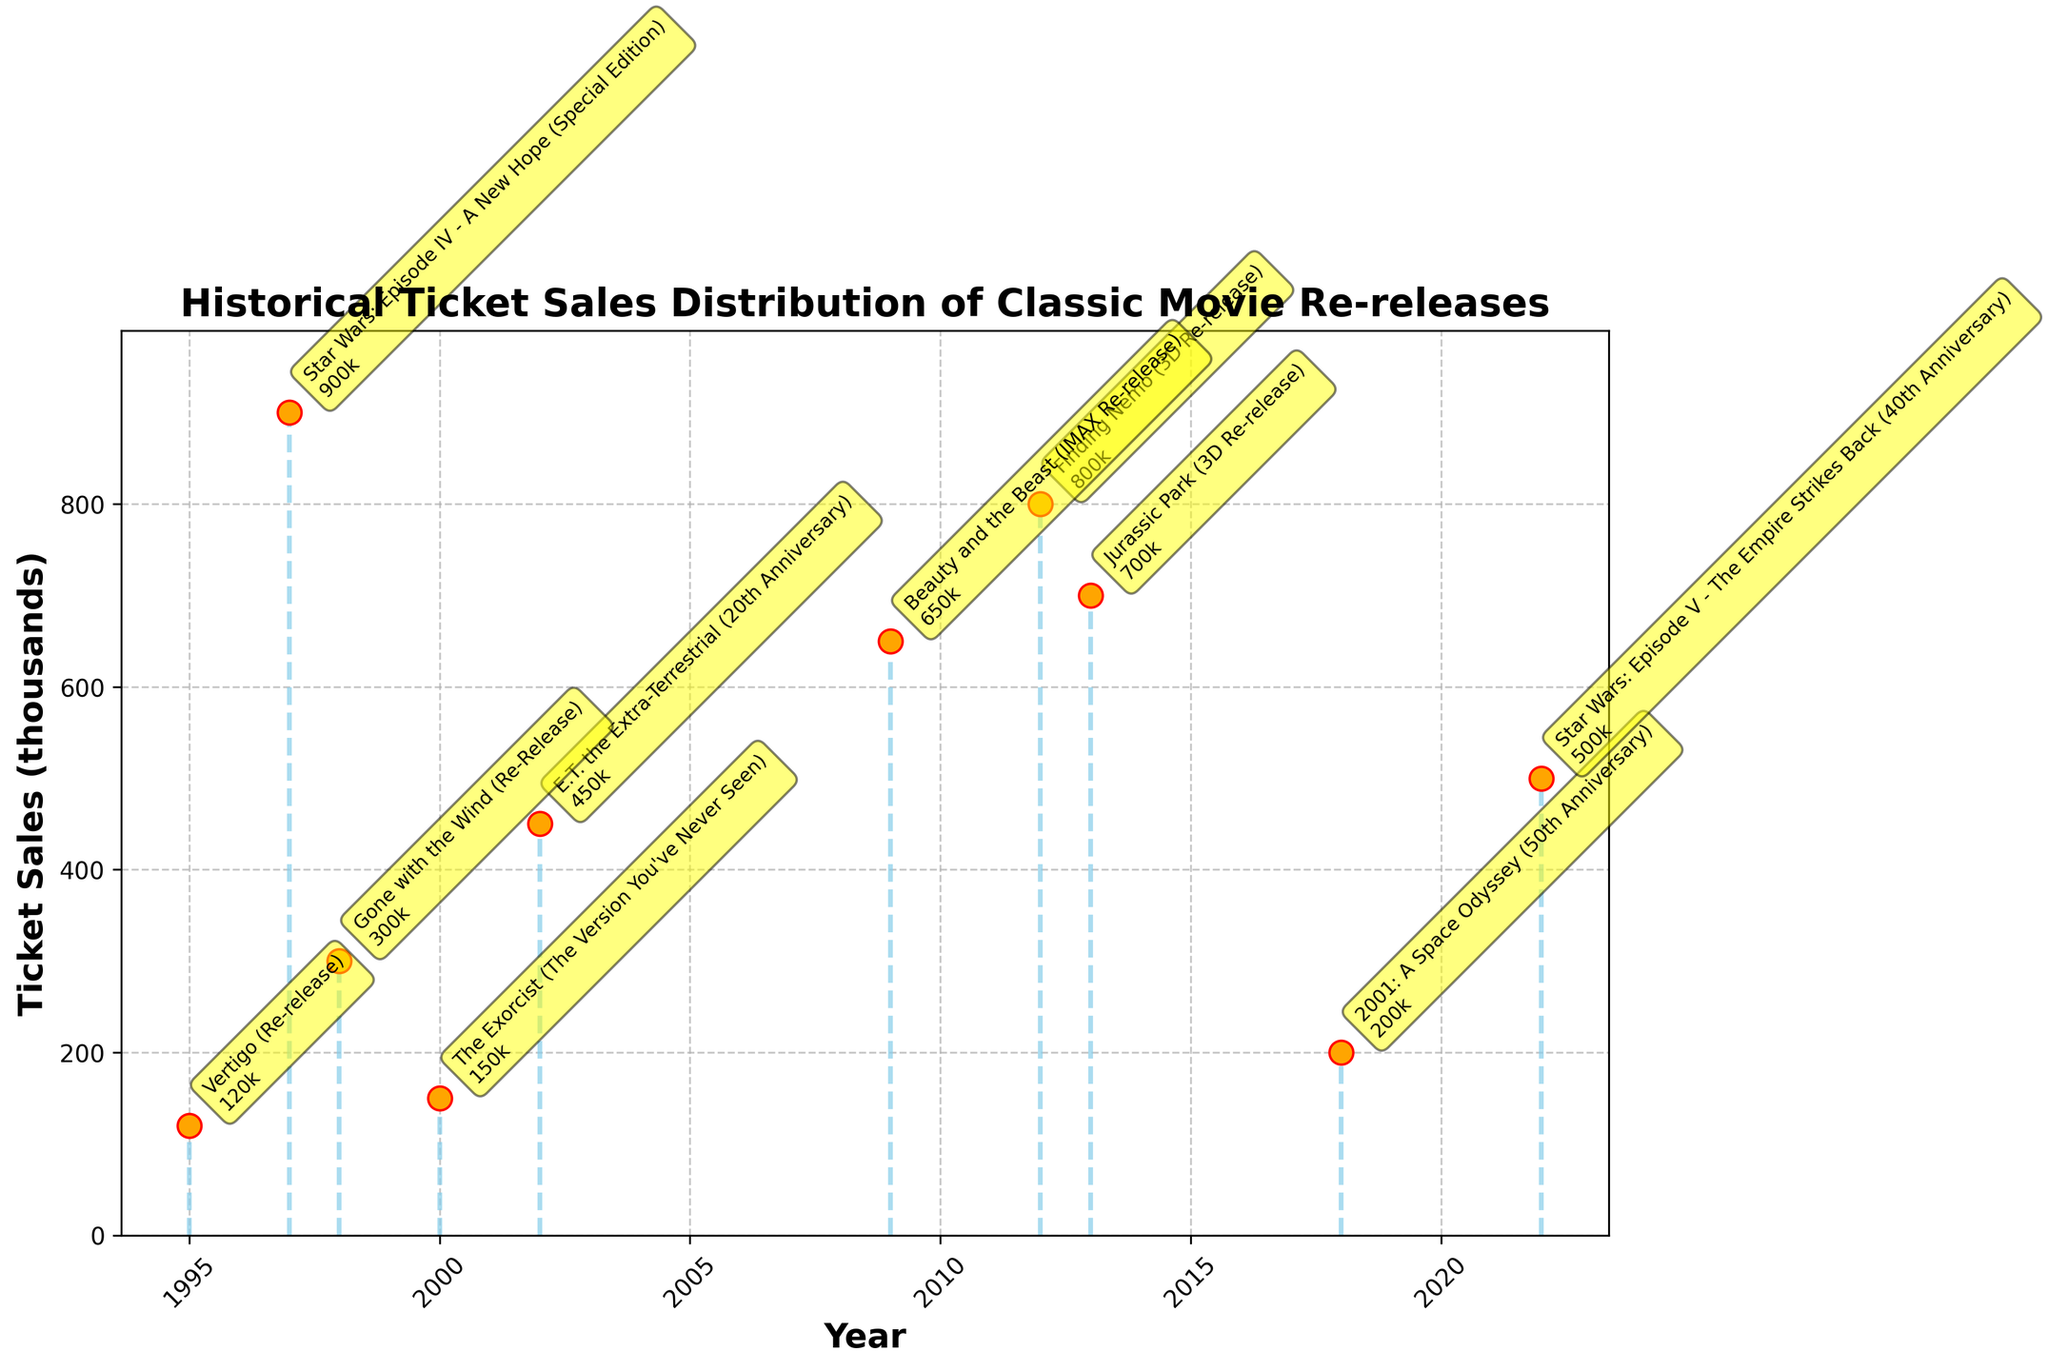Which classic movie re-release had the highest ticket sales? The highest ticket sales can be found by looking for the tallest stem in the plot. The tallest stem corresponds to "Star Wars: Episode IV - A New Hope (Special Edition)" released in 1997, which had 900 thousand tickets sold.
Answer: Star Wars: Episode IV - A New Hope (Special Edition) How many movies had ticket sales above 500 thousand? To answer this, count the stems that go above the 500 thousand mark. The movies that have ticket sales above 500 thousand are "Star Wars: Episode IV - A New Hope (Special Edition)" (900k), "Finding Nemo (3D Re-release)" (800k), "Jurassic Park (3D Re-release)" (700k), and "Beauty and the Beast (IMAX Re-release)" (650k).
Answer: 4 What year did "The Exorcist (The Version You've Never Seen)" re-release and how many tickets were sold? Locate the label for "The Exorcist (The Version You've Never Seen)" on the plot and read its associated year and ticket sales. It was re-released in the year 2000 and had 150 thousand ticket sales.
Answer: 2000, 150k What is the difference in ticket sales between "Finding Nemo (3D Re-release)" and "E.T. the Extra-Terrestrial (20th Anniversary)"? Locate the stems of "Finding Nemo (3D Re-release)" and "E.T. the Extra-Terrestrial (20th Anniversary)", then calculate the difference in their ticket sales: 800k - 450k = 350k.
Answer: 350k Which movie re-release has the lowest ticket sales, and how many tickets were sold? Find the shortest stem; the shortest stem corresponds to "Vertigo (Re-release)" in 1995 with 120 thousand tickets sold.
Answer: Vertigo (Re-release), 120k What is the average ticket sales across all the re-releases shown? Add up all the ticket sales values and divide by the number of movies. Total ticket sales = 900 + 450 + 300 + 150 + 120 + 800 + 200 + 700 + 650 + 500 = 4770k. Number of movies = 10. Average = 4770k / 10 = 477k.
Answer: 477k Which re-release occurred in 2022 and how many tickets were sold? Locate the label for the year 2022 on the plot, which is "Star Wars: Episode V - The Empire Strikes Back (40th Anniversary)" and had 500 thousand tickets sold.
Answer: Star Wars: Episode V - The Empire Strikes Back (40th Anniversary), 500k What are the combined ticket sales of the movies released before 2000? Sum the ticket sales of movies released in 1995, 1997, 1998, and 1999. Ticket sales = 120k (Vertigo) + 900k (Star Wars: Episode IV - A New Hope) + 300k (Gone with the Wind) + 150k (The Exorcist) = 1470k.
Answer: 1470k 